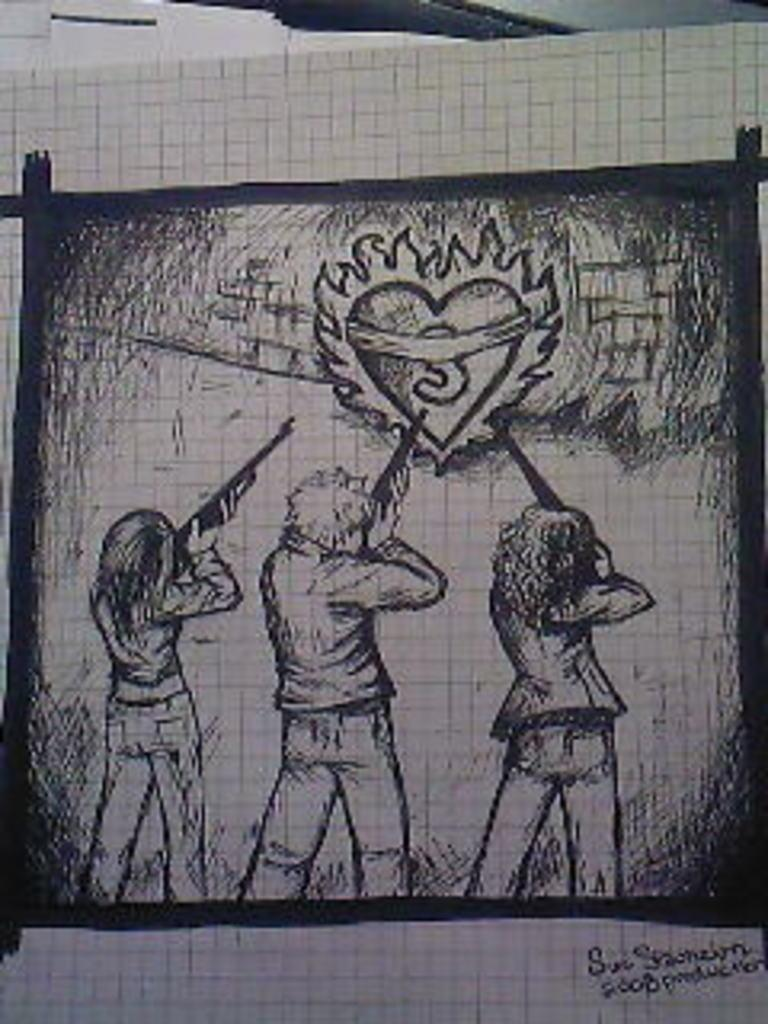What is the main subject of the image? The main subject of the image is a sketch. What does the sketch depict? The sketch depicts three people. What are the people in the sketch holding? The people in the sketch are holding guns. Are there any words or letters in the image? Yes, there is text present in the image. What type of cheese is being used as a crook in the image? There is no cheese or crook present in the image; it features a sketch of three people holding guns. Can you describe the yard where the people in the sketch are standing? There is no yard depicted in the image; it only shows a sketch of three people holding guns. 